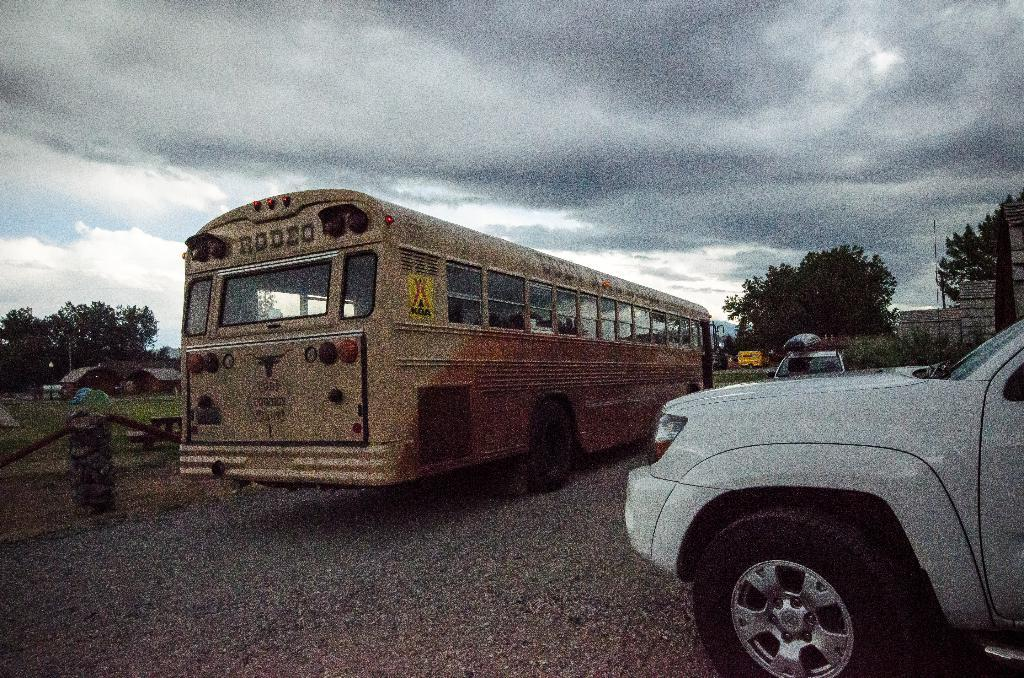<image>
Share a concise interpretation of the image provided. An old bus with Rodeo and Cody Cowboy stages written on the back 